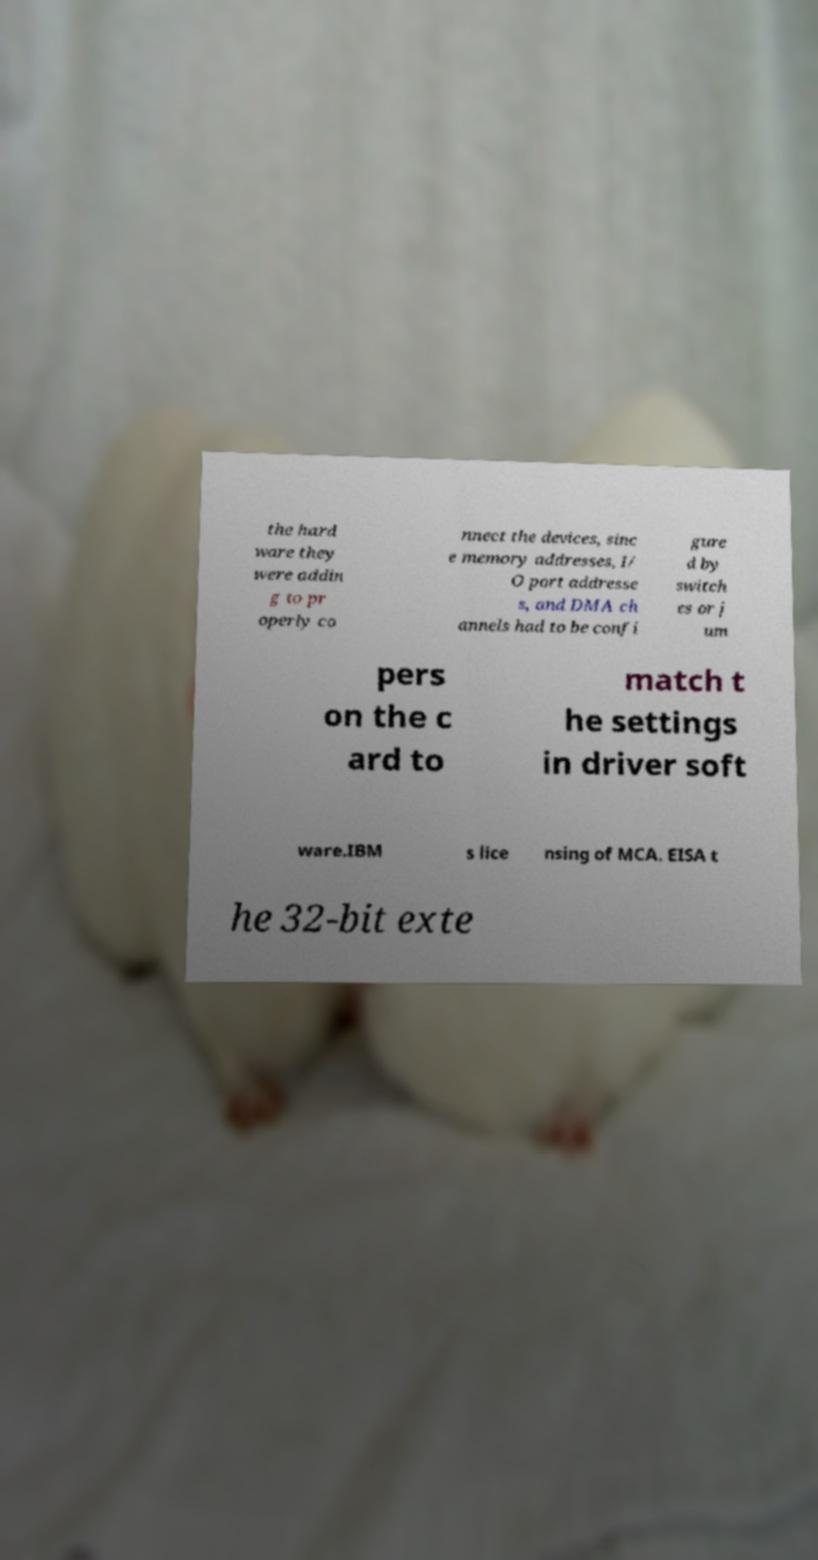Can you accurately transcribe the text from the provided image for me? the hard ware they were addin g to pr operly co nnect the devices, sinc e memory addresses, I/ O port addresse s, and DMA ch annels had to be confi gure d by switch es or j um pers on the c ard to match t he settings in driver soft ware.IBM s lice nsing of MCA. EISA t he 32-bit exte 